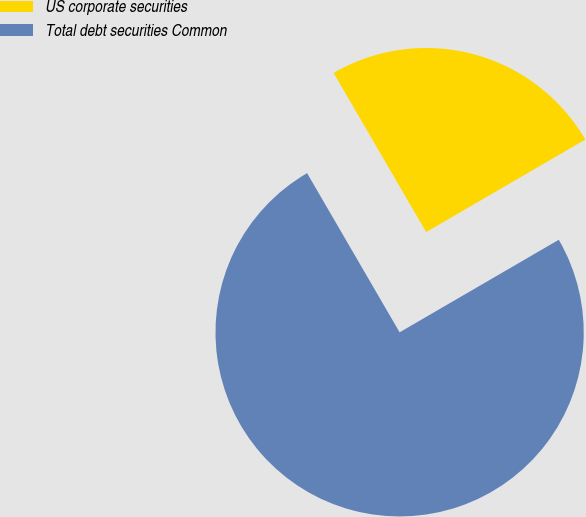<chart> <loc_0><loc_0><loc_500><loc_500><pie_chart><fcel>US corporate securities<fcel>Total debt securities Common<nl><fcel>25.0%<fcel>75.0%<nl></chart> 